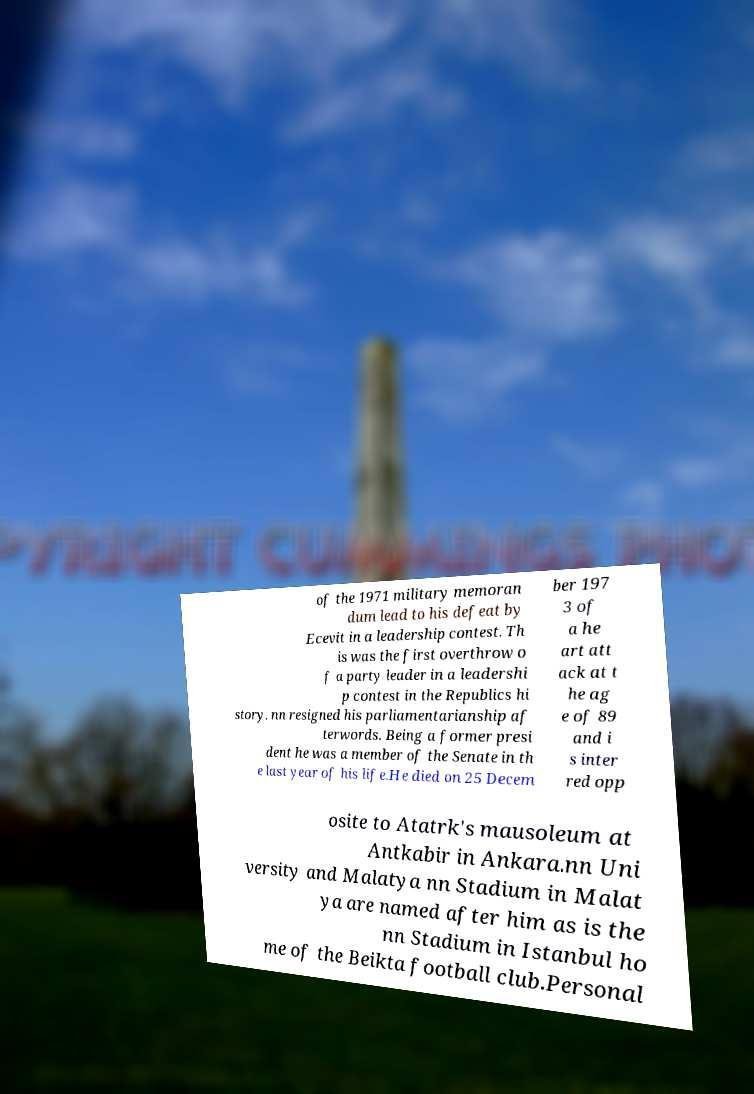There's text embedded in this image that I need extracted. Can you transcribe it verbatim? of the 1971 military memoran dum lead to his defeat by Ecevit in a leadership contest. Th is was the first overthrow o f a party leader in a leadershi p contest in the Republics hi story. nn resigned his parliamentarianship af terwords. Being a former presi dent he was a member of the Senate in th e last year of his life.He died on 25 Decem ber 197 3 of a he art att ack at t he ag e of 89 and i s inter red opp osite to Atatrk's mausoleum at Antkabir in Ankara.nn Uni versity and Malatya nn Stadium in Malat ya are named after him as is the nn Stadium in Istanbul ho me of the Beikta football club.Personal 